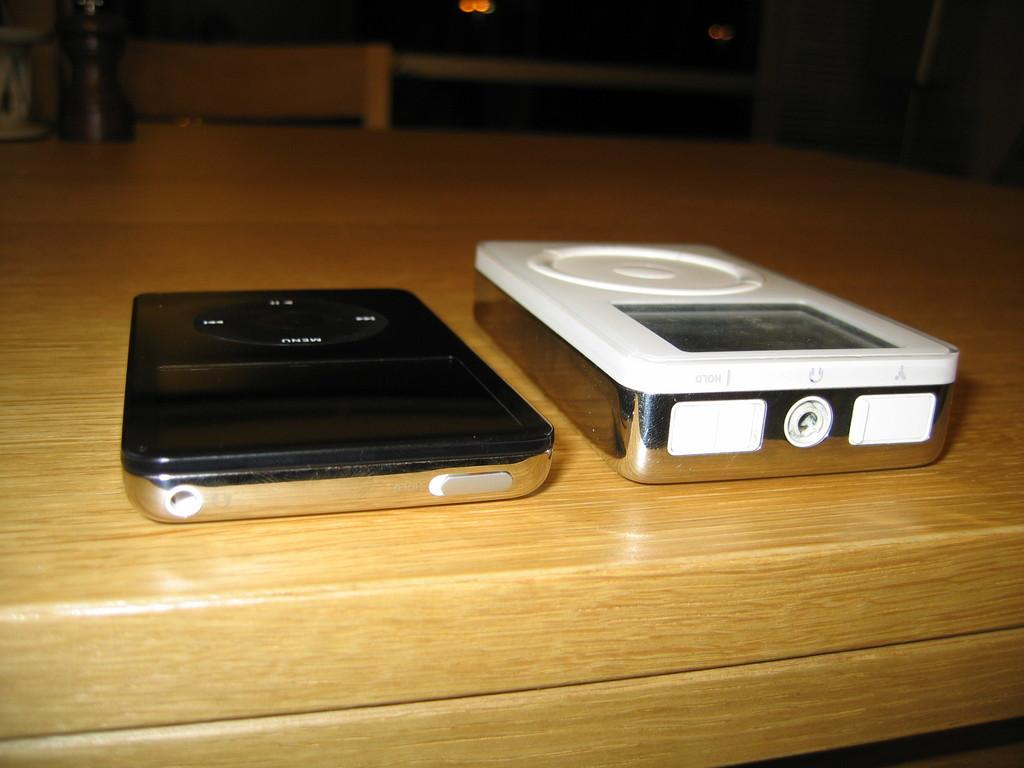What electronic devices are present in the image? There are two Ipods in the image. Where are the Ipods located? The Ipods are on a table. What type of advertisement can be seen on the bushes in the image? There are no bushes or advertisements present in the image; it only features two Ipods on a table. 